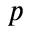Convert formula to latex. <formula><loc_0><loc_0><loc_500><loc_500>p</formula> 